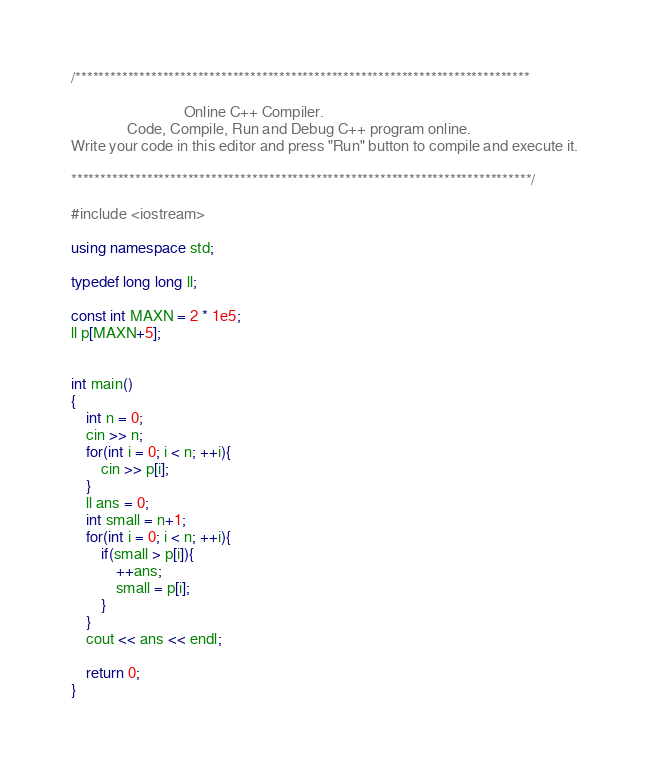<code> <loc_0><loc_0><loc_500><loc_500><_C++_>/******************************************************************************

                              Online C++ Compiler.
               Code, Compile, Run and Debug C++ program online.
Write your code in this editor and press "Run" button to compile and execute it.

*******************************************************************************/

#include <iostream>

using namespace std;

typedef long long ll;

const int MAXN = 2 * 1e5;
ll p[MAXN+5];


int main()
{
    int n = 0;
    cin >> n;
    for(int i = 0; i < n; ++i){
        cin >> p[i];
    }
    ll ans = 0;
    int small = n+1;
    for(int i = 0; i < n; ++i){
        if(small > p[i]){
            ++ans;
            small = p[i];
        }
    }
    cout << ans << endl;

    return 0;
}
</code> 